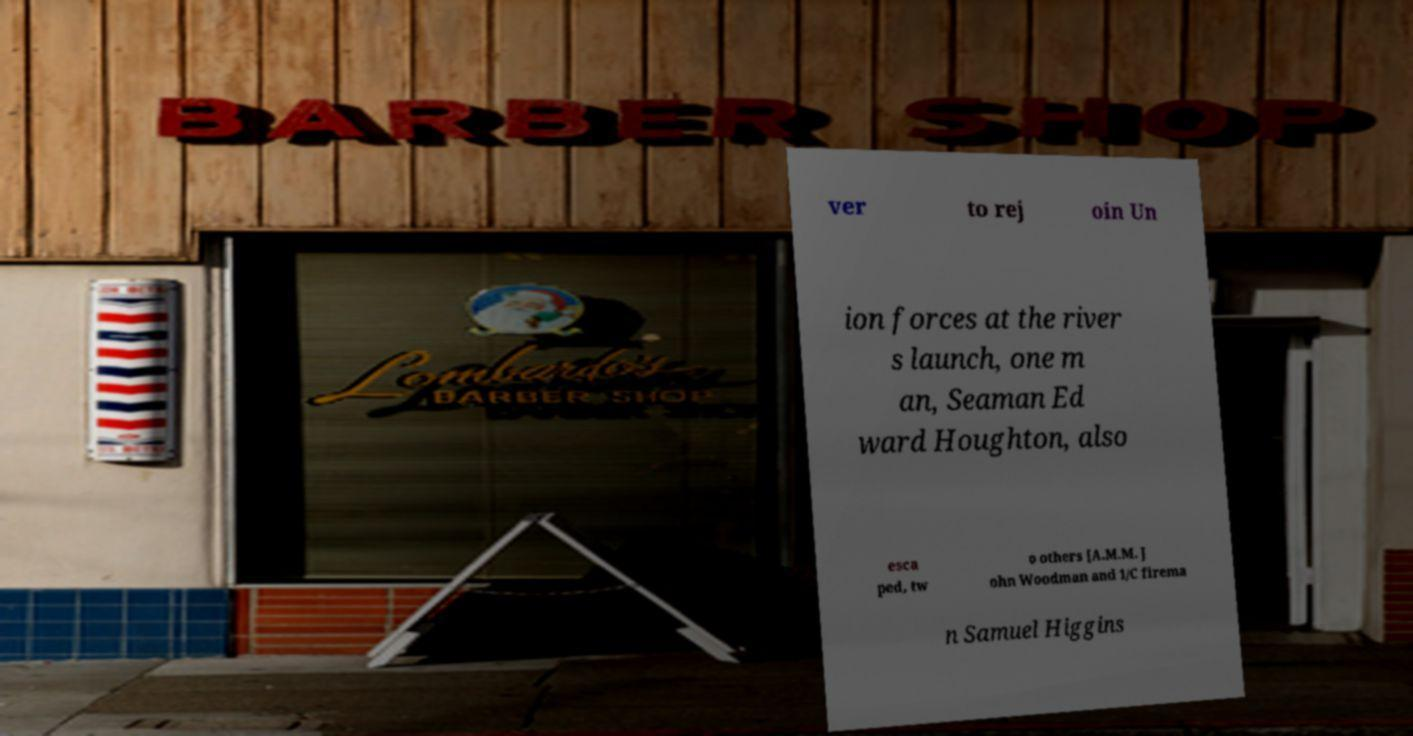What messages or text are displayed in this image? I need them in a readable, typed format. ver to rej oin Un ion forces at the river s launch, one m an, Seaman Ed ward Houghton, also esca ped, tw o others [A.M.M. J ohn Woodman and 1/C firema n Samuel Higgins 